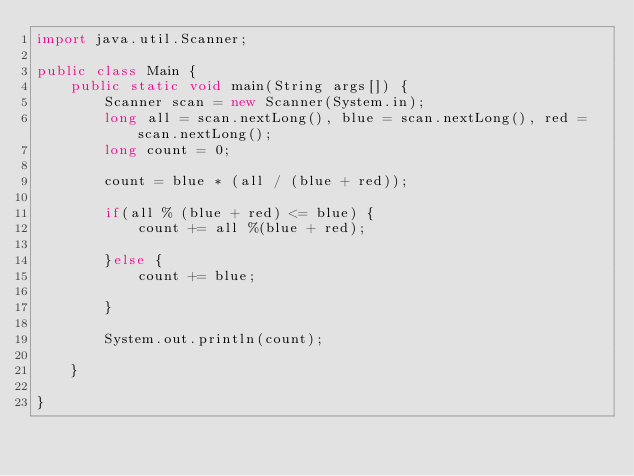<code> <loc_0><loc_0><loc_500><loc_500><_Java_>import java.util.Scanner;

public class Main {
	public static void main(String args[]) {
		Scanner scan = new Scanner(System.in);
		long all = scan.nextLong(), blue = scan.nextLong(), red = scan.nextLong();
		long count = 0;
		
		count = blue * (all / (blue + red));
		
		if(all % (blue + red) <= blue) {
			count += all %(blue + red);
			
		}else {
			count += blue;
			
		}
		
		System.out.println(count);
		
	}
	
}</code> 